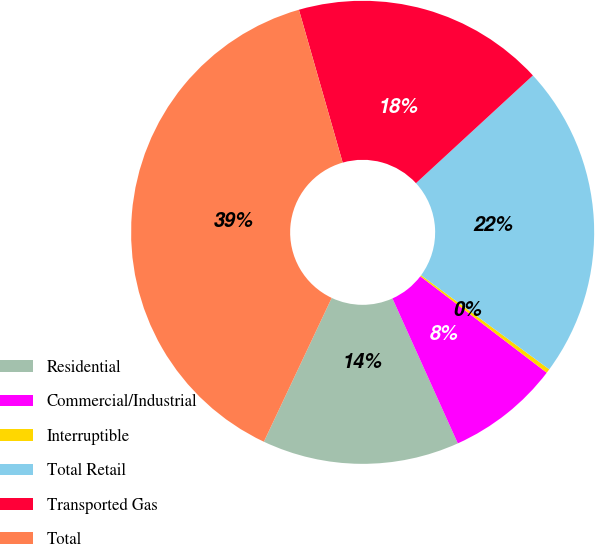Convert chart to OTSL. <chart><loc_0><loc_0><loc_500><loc_500><pie_chart><fcel>Residential<fcel>Commercial/Industrial<fcel>Interruptible<fcel>Total Retail<fcel>Transported Gas<fcel>Total<nl><fcel>13.76%<fcel>7.89%<fcel>0.29%<fcel>21.93%<fcel>17.59%<fcel>38.55%<nl></chart> 